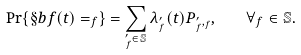Convert formula to latex. <formula><loc_0><loc_0><loc_500><loc_500>\Pr \{ \S b f ( t ) = _ { f } \} = \sum _ { _ { f } ^ { \prime } \in \mathbb { S } } \lambda _ { _ { f } ^ { \prime } } ( t ) P _ { _ { f } ^ { \prime } , _ { f } } , \quad \forall _ { f } \in \mathbb { S } .</formula> 